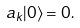Convert formula to latex. <formula><loc_0><loc_0><loc_500><loc_500>\ a _ { k } | 0 \rangle = 0 .</formula> 